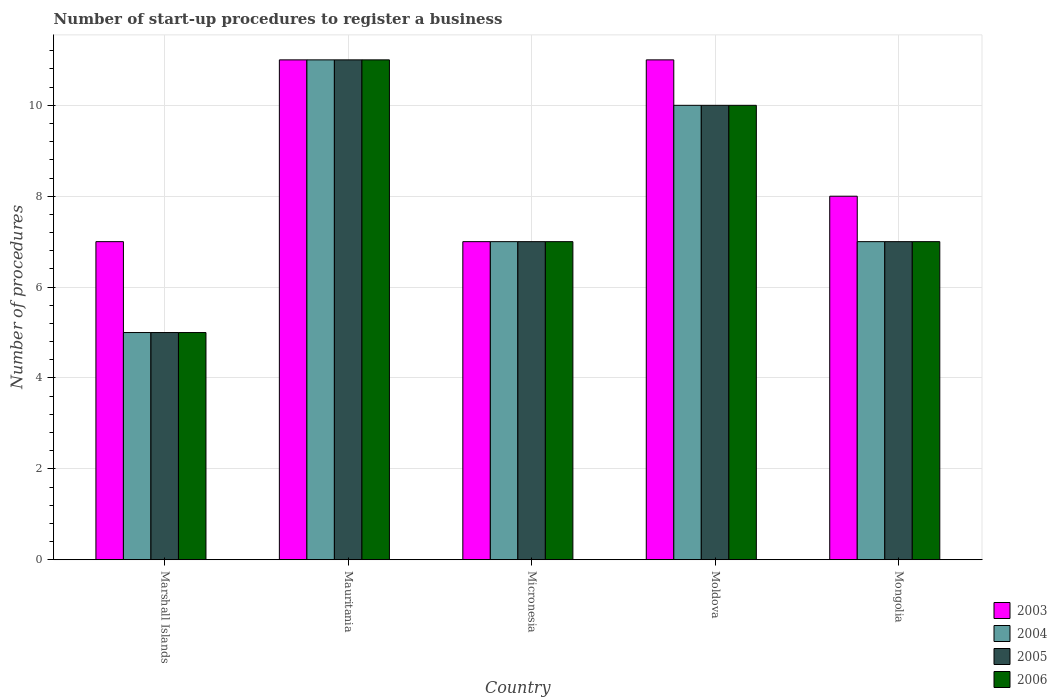How many groups of bars are there?
Your answer should be compact. 5. Are the number of bars per tick equal to the number of legend labels?
Your response must be concise. Yes. Are the number of bars on each tick of the X-axis equal?
Keep it short and to the point. Yes. How many bars are there on the 5th tick from the right?
Make the answer very short. 4. What is the label of the 5th group of bars from the left?
Make the answer very short. Mongolia. What is the number of procedures required to register a business in 2004 in Mongolia?
Ensure brevity in your answer.  7. In which country was the number of procedures required to register a business in 2005 maximum?
Your answer should be compact. Mauritania. In which country was the number of procedures required to register a business in 2003 minimum?
Make the answer very short. Marshall Islands. What is the difference between the number of procedures required to register a business in 2005 in Moldova and the number of procedures required to register a business in 2006 in Mongolia?
Provide a succinct answer. 3. What is the difference between the number of procedures required to register a business of/in 2004 and number of procedures required to register a business of/in 2005 in Marshall Islands?
Make the answer very short. 0. What is the ratio of the number of procedures required to register a business in 2005 in Marshall Islands to that in Micronesia?
Give a very brief answer. 0.71. Is the number of procedures required to register a business in 2003 in Micronesia less than that in Moldova?
Your answer should be compact. Yes. What is the difference between the highest and the second highest number of procedures required to register a business in 2006?
Offer a very short reply. -1. Is the sum of the number of procedures required to register a business in 2004 in Moldova and Mongolia greater than the maximum number of procedures required to register a business in 2005 across all countries?
Your answer should be compact. Yes. Is it the case that in every country, the sum of the number of procedures required to register a business in 2004 and number of procedures required to register a business in 2006 is greater than the sum of number of procedures required to register a business in 2003 and number of procedures required to register a business in 2005?
Keep it short and to the point. No. What does the 3rd bar from the left in Moldova represents?
Your answer should be compact. 2005. What does the 1st bar from the right in Marshall Islands represents?
Offer a very short reply. 2006. Is it the case that in every country, the sum of the number of procedures required to register a business in 2004 and number of procedures required to register a business in 2005 is greater than the number of procedures required to register a business in 2006?
Provide a short and direct response. Yes. How many bars are there?
Provide a succinct answer. 20. How many legend labels are there?
Keep it short and to the point. 4. What is the title of the graph?
Your answer should be very brief. Number of start-up procedures to register a business. What is the label or title of the Y-axis?
Your response must be concise. Number of procedures. What is the Number of procedures of 2004 in Marshall Islands?
Offer a very short reply. 5. What is the Number of procedures of 2005 in Marshall Islands?
Provide a short and direct response. 5. What is the Number of procedures of 2005 in Mauritania?
Provide a succinct answer. 11. What is the Number of procedures of 2006 in Micronesia?
Provide a succinct answer. 7. What is the Number of procedures of 2003 in Moldova?
Provide a succinct answer. 11. What is the Number of procedures in 2004 in Mongolia?
Your response must be concise. 7. What is the Number of procedures of 2005 in Mongolia?
Your answer should be very brief. 7. Across all countries, what is the maximum Number of procedures in 2003?
Make the answer very short. 11. Across all countries, what is the maximum Number of procedures in 2005?
Provide a succinct answer. 11. Across all countries, what is the minimum Number of procedures in 2004?
Offer a terse response. 5. Across all countries, what is the minimum Number of procedures in 2005?
Keep it short and to the point. 5. Across all countries, what is the minimum Number of procedures of 2006?
Give a very brief answer. 5. What is the total Number of procedures in 2003 in the graph?
Offer a terse response. 44. What is the total Number of procedures in 2004 in the graph?
Offer a very short reply. 40. What is the total Number of procedures of 2005 in the graph?
Provide a succinct answer. 40. What is the total Number of procedures of 2006 in the graph?
Provide a succinct answer. 40. What is the difference between the Number of procedures of 2003 in Marshall Islands and that in Mauritania?
Provide a succinct answer. -4. What is the difference between the Number of procedures of 2004 in Marshall Islands and that in Mauritania?
Provide a succinct answer. -6. What is the difference between the Number of procedures in 2003 in Marshall Islands and that in Micronesia?
Make the answer very short. 0. What is the difference between the Number of procedures in 2004 in Marshall Islands and that in Micronesia?
Ensure brevity in your answer.  -2. What is the difference between the Number of procedures in 2006 in Marshall Islands and that in Micronesia?
Provide a short and direct response. -2. What is the difference between the Number of procedures of 2003 in Marshall Islands and that in Moldova?
Your answer should be very brief. -4. What is the difference between the Number of procedures of 2005 in Marshall Islands and that in Moldova?
Offer a very short reply. -5. What is the difference between the Number of procedures of 2006 in Marshall Islands and that in Moldova?
Your answer should be very brief. -5. What is the difference between the Number of procedures in 2006 in Marshall Islands and that in Mongolia?
Give a very brief answer. -2. What is the difference between the Number of procedures of 2003 in Mauritania and that in Micronesia?
Provide a succinct answer. 4. What is the difference between the Number of procedures in 2003 in Mauritania and that in Moldova?
Give a very brief answer. 0. What is the difference between the Number of procedures of 2005 in Mauritania and that in Moldova?
Keep it short and to the point. 1. What is the difference between the Number of procedures of 2005 in Mauritania and that in Mongolia?
Provide a short and direct response. 4. What is the difference between the Number of procedures in 2006 in Mauritania and that in Mongolia?
Your answer should be compact. 4. What is the difference between the Number of procedures of 2003 in Micronesia and that in Moldova?
Ensure brevity in your answer.  -4. What is the difference between the Number of procedures of 2004 in Micronesia and that in Moldova?
Your response must be concise. -3. What is the difference between the Number of procedures of 2006 in Micronesia and that in Moldova?
Your answer should be very brief. -3. What is the difference between the Number of procedures in 2005 in Micronesia and that in Mongolia?
Ensure brevity in your answer.  0. What is the difference between the Number of procedures in 2006 in Micronesia and that in Mongolia?
Your answer should be compact. 0. What is the difference between the Number of procedures in 2003 in Moldova and that in Mongolia?
Provide a short and direct response. 3. What is the difference between the Number of procedures of 2005 in Moldova and that in Mongolia?
Keep it short and to the point. 3. What is the difference between the Number of procedures in 2006 in Moldova and that in Mongolia?
Give a very brief answer. 3. What is the difference between the Number of procedures of 2003 in Marshall Islands and the Number of procedures of 2004 in Mauritania?
Ensure brevity in your answer.  -4. What is the difference between the Number of procedures of 2003 in Marshall Islands and the Number of procedures of 2006 in Mauritania?
Keep it short and to the point. -4. What is the difference between the Number of procedures of 2004 in Marshall Islands and the Number of procedures of 2005 in Mauritania?
Your answer should be compact. -6. What is the difference between the Number of procedures of 2003 in Marshall Islands and the Number of procedures of 2005 in Micronesia?
Offer a very short reply. 0. What is the difference between the Number of procedures in 2004 in Marshall Islands and the Number of procedures in 2006 in Micronesia?
Provide a short and direct response. -2. What is the difference between the Number of procedures of 2005 in Marshall Islands and the Number of procedures of 2006 in Micronesia?
Offer a terse response. -2. What is the difference between the Number of procedures in 2003 in Marshall Islands and the Number of procedures in 2004 in Moldova?
Keep it short and to the point. -3. What is the difference between the Number of procedures of 2003 in Marshall Islands and the Number of procedures of 2006 in Moldova?
Provide a succinct answer. -3. What is the difference between the Number of procedures in 2004 in Marshall Islands and the Number of procedures in 2006 in Moldova?
Make the answer very short. -5. What is the difference between the Number of procedures in 2005 in Marshall Islands and the Number of procedures in 2006 in Moldova?
Offer a very short reply. -5. What is the difference between the Number of procedures of 2004 in Marshall Islands and the Number of procedures of 2006 in Mongolia?
Offer a terse response. -2. What is the difference between the Number of procedures in 2005 in Marshall Islands and the Number of procedures in 2006 in Mongolia?
Give a very brief answer. -2. What is the difference between the Number of procedures in 2003 in Mauritania and the Number of procedures in 2005 in Micronesia?
Your answer should be very brief. 4. What is the difference between the Number of procedures in 2003 in Mauritania and the Number of procedures in 2006 in Micronesia?
Your answer should be compact. 4. What is the difference between the Number of procedures in 2005 in Mauritania and the Number of procedures in 2006 in Micronesia?
Provide a succinct answer. 4. What is the difference between the Number of procedures of 2003 in Mauritania and the Number of procedures of 2005 in Moldova?
Your answer should be compact. 1. What is the difference between the Number of procedures of 2003 in Mauritania and the Number of procedures of 2006 in Moldova?
Your answer should be compact. 1. What is the difference between the Number of procedures in 2004 in Mauritania and the Number of procedures in 2005 in Moldova?
Your response must be concise. 1. What is the difference between the Number of procedures in 2004 in Mauritania and the Number of procedures in 2006 in Moldova?
Provide a short and direct response. 1. What is the difference between the Number of procedures of 2003 in Mauritania and the Number of procedures of 2004 in Mongolia?
Your answer should be compact. 4. What is the difference between the Number of procedures in 2004 in Mauritania and the Number of procedures in 2006 in Mongolia?
Provide a succinct answer. 4. What is the difference between the Number of procedures of 2003 in Micronesia and the Number of procedures of 2004 in Moldova?
Make the answer very short. -3. What is the difference between the Number of procedures of 2003 in Micronesia and the Number of procedures of 2005 in Moldova?
Offer a terse response. -3. What is the difference between the Number of procedures of 2003 in Micronesia and the Number of procedures of 2006 in Moldova?
Offer a terse response. -3. What is the difference between the Number of procedures of 2004 in Micronesia and the Number of procedures of 2006 in Moldova?
Your answer should be very brief. -3. What is the difference between the Number of procedures of 2003 in Micronesia and the Number of procedures of 2004 in Mongolia?
Your response must be concise. 0. What is the difference between the Number of procedures of 2003 in Micronesia and the Number of procedures of 2005 in Mongolia?
Your answer should be compact. 0. What is the difference between the Number of procedures in 2004 in Micronesia and the Number of procedures in 2005 in Mongolia?
Your answer should be compact. 0. What is the difference between the Number of procedures in 2003 in Moldova and the Number of procedures in 2004 in Mongolia?
Give a very brief answer. 4. What is the difference between the Number of procedures of 2003 in Moldova and the Number of procedures of 2006 in Mongolia?
Offer a very short reply. 4. What is the difference between the Number of procedures in 2004 in Moldova and the Number of procedures in 2006 in Mongolia?
Provide a short and direct response. 3. What is the difference between the Number of procedures of 2005 in Moldova and the Number of procedures of 2006 in Mongolia?
Your answer should be compact. 3. What is the average Number of procedures in 2004 per country?
Offer a terse response. 8. What is the difference between the Number of procedures of 2003 and Number of procedures of 2004 in Marshall Islands?
Your answer should be compact. 2. What is the difference between the Number of procedures in 2003 and Number of procedures in 2006 in Marshall Islands?
Provide a short and direct response. 2. What is the difference between the Number of procedures in 2004 and Number of procedures in 2005 in Marshall Islands?
Offer a terse response. 0. What is the difference between the Number of procedures of 2004 and Number of procedures of 2006 in Marshall Islands?
Provide a succinct answer. 0. What is the difference between the Number of procedures in 2005 and Number of procedures in 2006 in Marshall Islands?
Provide a short and direct response. 0. What is the difference between the Number of procedures of 2003 and Number of procedures of 2005 in Mauritania?
Your response must be concise. 0. What is the difference between the Number of procedures of 2003 and Number of procedures of 2004 in Micronesia?
Keep it short and to the point. 0. What is the difference between the Number of procedures of 2003 and Number of procedures of 2005 in Micronesia?
Provide a short and direct response. 0. What is the difference between the Number of procedures in 2003 and Number of procedures in 2006 in Micronesia?
Provide a succinct answer. 0. What is the difference between the Number of procedures of 2004 and Number of procedures of 2005 in Micronesia?
Offer a terse response. 0. What is the difference between the Number of procedures of 2004 and Number of procedures of 2006 in Micronesia?
Ensure brevity in your answer.  0. What is the difference between the Number of procedures in 2005 and Number of procedures in 2006 in Micronesia?
Ensure brevity in your answer.  0. What is the difference between the Number of procedures in 2003 and Number of procedures in 2004 in Moldova?
Your response must be concise. 1. What is the difference between the Number of procedures in 2003 and Number of procedures in 2005 in Moldova?
Keep it short and to the point. 1. What is the difference between the Number of procedures in 2003 and Number of procedures in 2006 in Moldova?
Your response must be concise. 1. What is the difference between the Number of procedures in 2005 and Number of procedures in 2006 in Moldova?
Provide a short and direct response. 0. What is the difference between the Number of procedures of 2003 and Number of procedures of 2004 in Mongolia?
Offer a terse response. 1. What is the difference between the Number of procedures in 2003 and Number of procedures in 2005 in Mongolia?
Offer a very short reply. 1. What is the difference between the Number of procedures of 2003 and Number of procedures of 2006 in Mongolia?
Provide a short and direct response. 1. What is the difference between the Number of procedures in 2004 and Number of procedures in 2006 in Mongolia?
Provide a succinct answer. 0. What is the ratio of the Number of procedures of 2003 in Marshall Islands to that in Mauritania?
Offer a very short reply. 0.64. What is the ratio of the Number of procedures in 2004 in Marshall Islands to that in Mauritania?
Offer a very short reply. 0.45. What is the ratio of the Number of procedures in 2005 in Marshall Islands to that in Mauritania?
Give a very brief answer. 0.45. What is the ratio of the Number of procedures in 2006 in Marshall Islands to that in Mauritania?
Make the answer very short. 0.45. What is the ratio of the Number of procedures of 2004 in Marshall Islands to that in Micronesia?
Provide a short and direct response. 0.71. What is the ratio of the Number of procedures of 2003 in Marshall Islands to that in Moldova?
Your response must be concise. 0.64. What is the ratio of the Number of procedures in 2004 in Marshall Islands to that in Moldova?
Give a very brief answer. 0.5. What is the ratio of the Number of procedures of 2005 in Marshall Islands to that in Moldova?
Your answer should be compact. 0.5. What is the ratio of the Number of procedures of 2006 in Marshall Islands to that in Moldova?
Ensure brevity in your answer.  0.5. What is the ratio of the Number of procedures of 2003 in Marshall Islands to that in Mongolia?
Your response must be concise. 0.88. What is the ratio of the Number of procedures of 2004 in Marshall Islands to that in Mongolia?
Offer a terse response. 0.71. What is the ratio of the Number of procedures of 2003 in Mauritania to that in Micronesia?
Ensure brevity in your answer.  1.57. What is the ratio of the Number of procedures of 2004 in Mauritania to that in Micronesia?
Provide a short and direct response. 1.57. What is the ratio of the Number of procedures of 2005 in Mauritania to that in Micronesia?
Offer a terse response. 1.57. What is the ratio of the Number of procedures in 2006 in Mauritania to that in Micronesia?
Provide a succinct answer. 1.57. What is the ratio of the Number of procedures in 2004 in Mauritania to that in Moldova?
Provide a succinct answer. 1.1. What is the ratio of the Number of procedures in 2003 in Mauritania to that in Mongolia?
Make the answer very short. 1.38. What is the ratio of the Number of procedures of 2004 in Mauritania to that in Mongolia?
Make the answer very short. 1.57. What is the ratio of the Number of procedures in 2005 in Mauritania to that in Mongolia?
Ensure brevity in your answer.  1.57. What is the ratio of the Number of procedures in 2006 in Mauritania to that in Mongolia?
Provide a short and direct response. 1.57. What is the ratio of the Number of procedures of 2003 in Micronesia to that in Moldova?
Provide a short and direct response. 0.64. What is the ratio of the Number of procedures of 2003 in Micronesia to that in Mongolia?
Make the answer very short. 0.88. What is the ratio of the Number of procedures of 2005 in Micronesia to that in Mongolia?
Provide a short and direct response. 1. What is the ratio of the Number of procedures in 2003 in Moldova to that in Mongolia?
Offer a terse response. 1.38. What is the ratio of the Number of procedures of 2004 in Moldova to that in Mongolia?
Your response must be concise. 1.43. What is the ratio of the Number of procedures in 2005 in Moldova to that in Mongolia?
Offer a very short reply. 1.43. What is the ratio of the Number of procedures of 2006 in Moldova to that in Mongolia?
Ensure brevity in your answer.  1.43. What is the difference between the highest and the second highest Number of procedures in 2003?
Your answer should be very brief. 0. What is the difference between the highest and the lowest Number of procedures of 2003?
Ensure brevity in your answer.  4. 